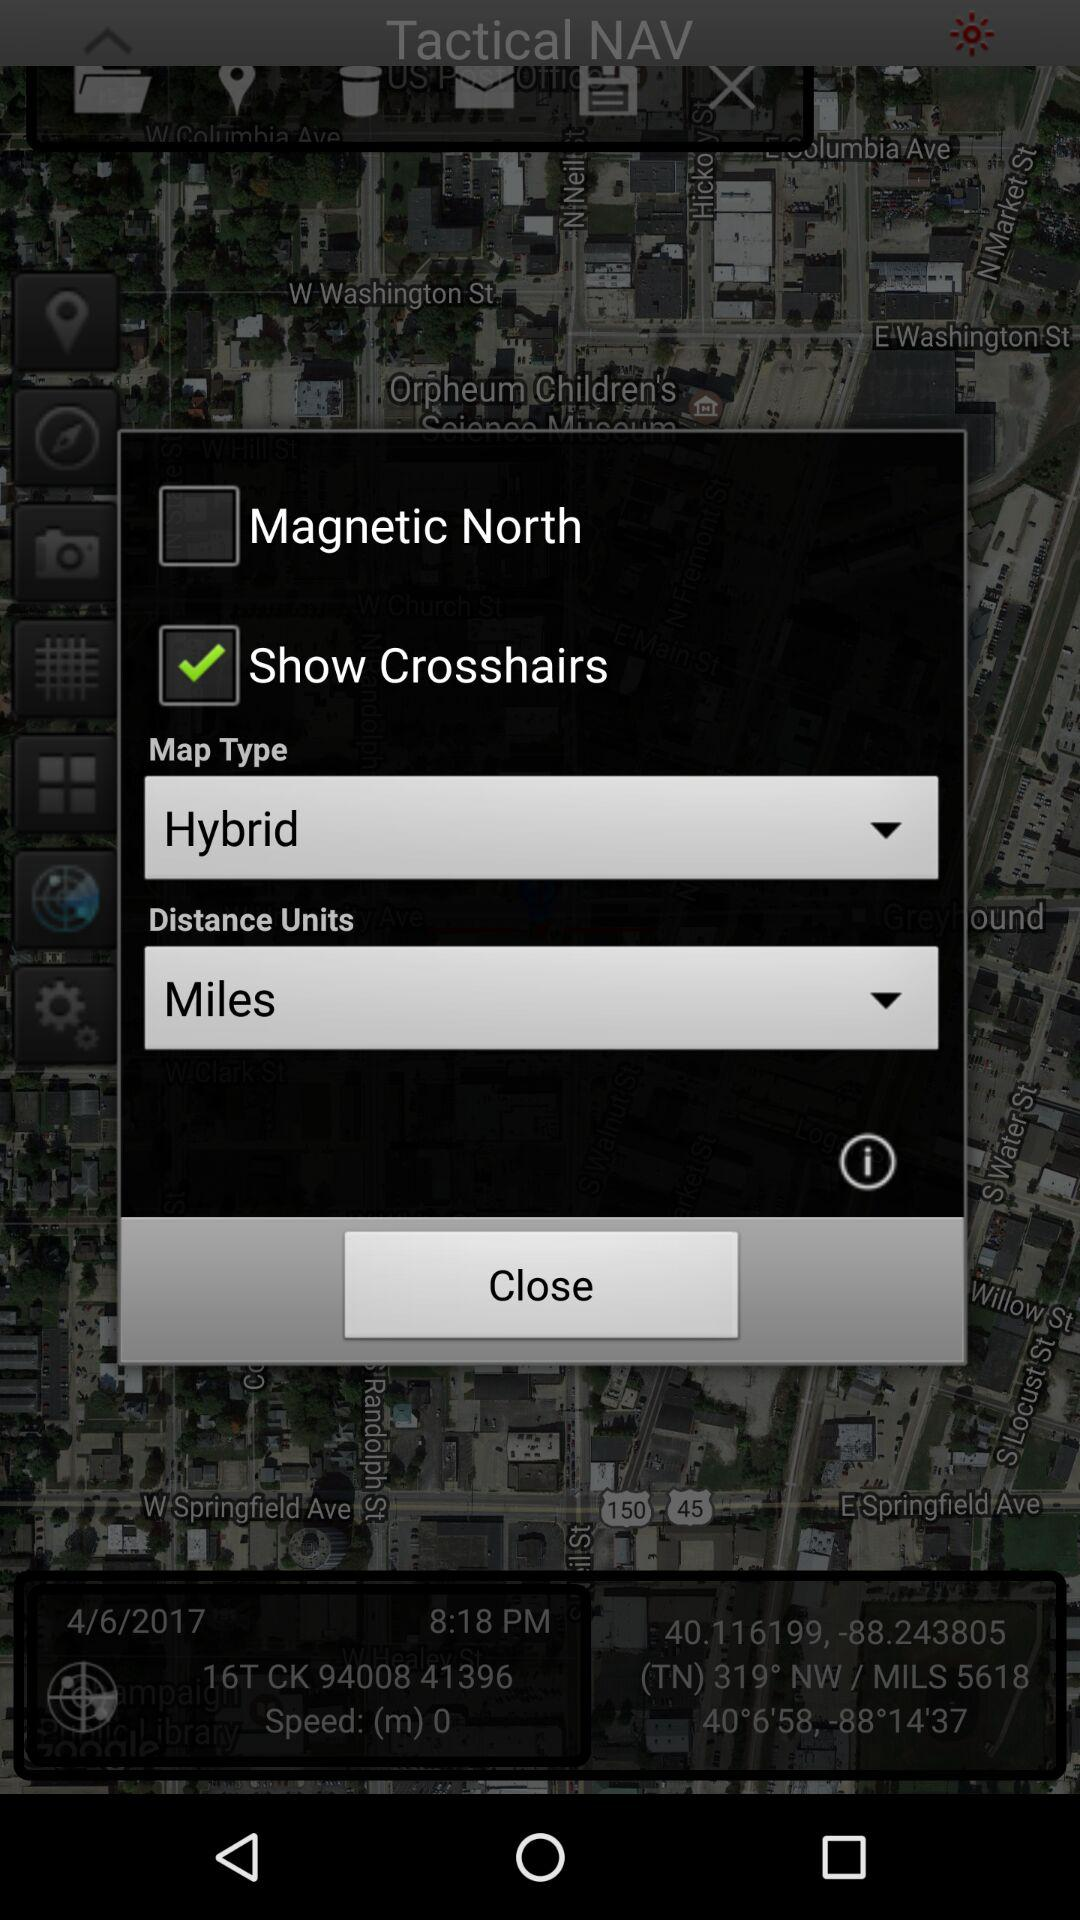What is the status of the "Show Crosshairs" setting? The status of the "Show Crosshairs" setting is "on". 